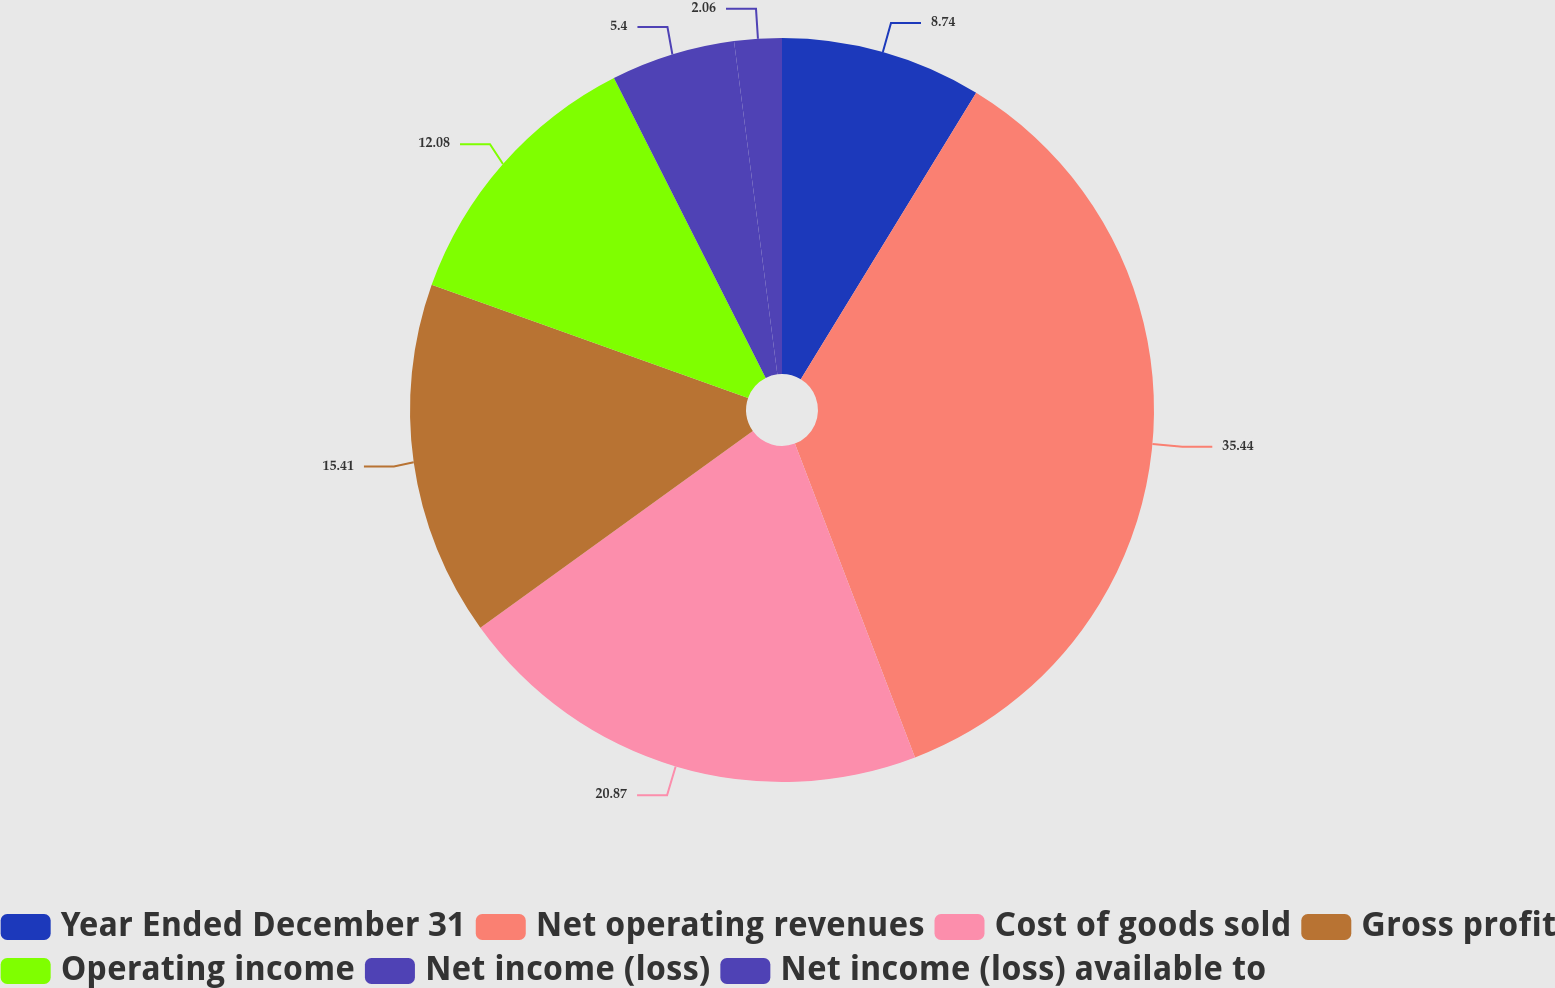Convert chart. <chart><loc_0><loc_0><loc_500><loc_500><pie_chart><fcel>Year Ended December 31<fcel>Net operating revenues<fcel>Cost of goods sold<fcel>Gross profit<fcel>Operating income<fcel>Net income (loss)<fcel>Net income (loss) available to<nl><fcel>8.74%<fcel>35.44%<fcel>20.87%<fcel>15.41%<fcel>12.08%<fcel>5.4%<fcel>2.06%<nl></chart> 